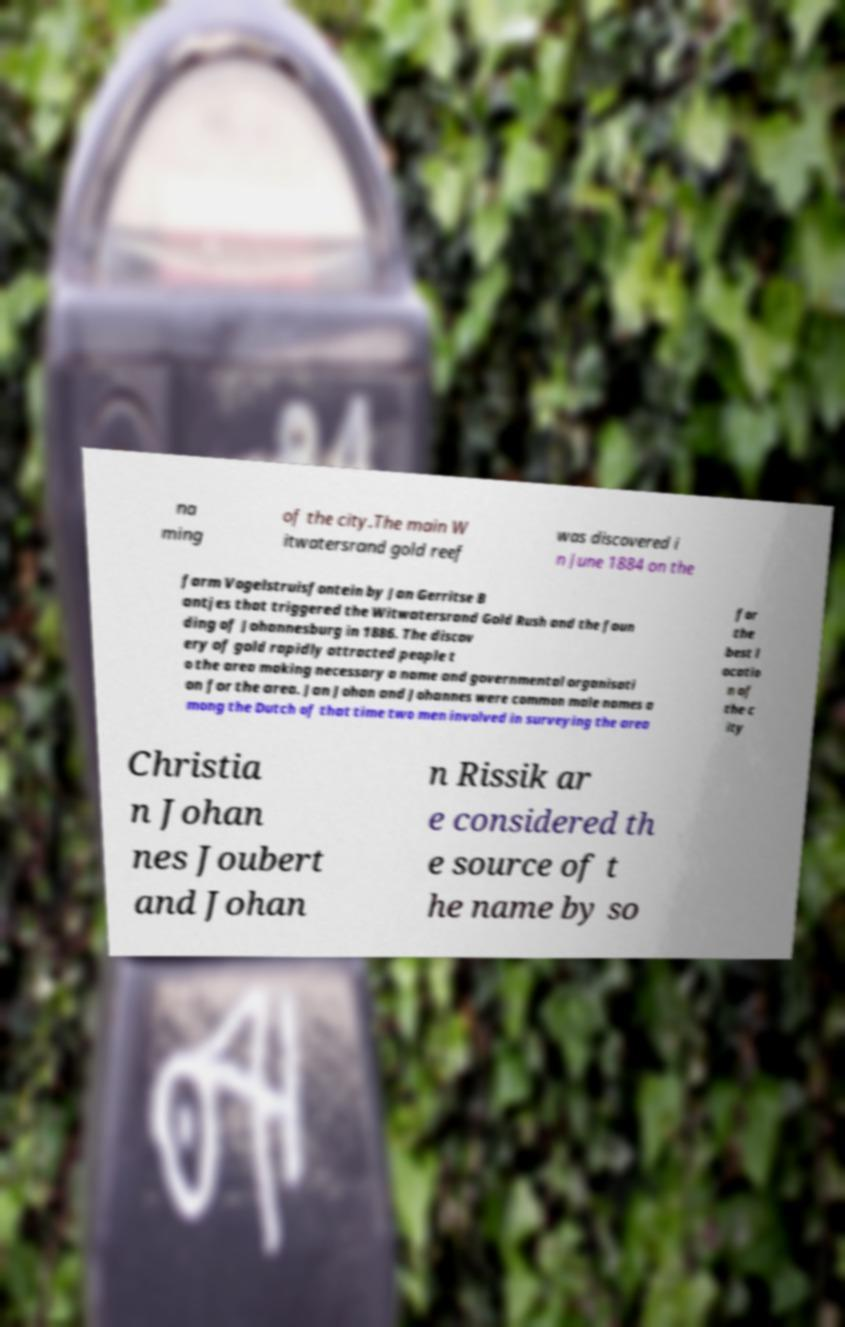For documentation purposes, I need the text within this image transcribed. Could you provide that? na ming of the city.The main W itwatersrand gold reef was discovered i n June 1884 on the farm Vogelstruisfontein by Jan Gerritse B antjes that triggered the Witwatersrand Gold Rush and the foun ding of Johannesburg in 1886. The discov ery of gold rapidly attracted people t o the area making necessary a name and governmental organisati on for the area. Jan Johan and Johannes were common male names a mong the Dutch of that time two men involved in surveying the area for the best l ocatio n of the c ity Christia n Johan nes Joubert and Johan n Rissik ar e considered th e source of t he name by so 